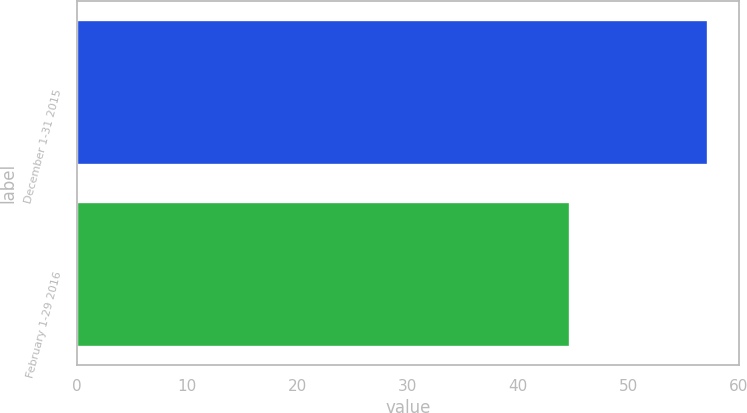<chart> <loc_0><loc_0><loc_500><loc_500><bar_chart><fcel>December 1-31 2015<fcel>February 1-29 2016<nl><fcel>57.21<fcel>44.71<nl></chart> 